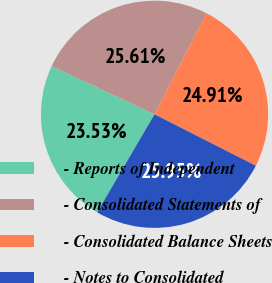Convert chart. <chart><loc_0><loc_0><loc_500><loc_500><pie_chart><fcel>- Reports of Independent<fcel>- Consolidated Statements of<fcel>- Consolidated Balance Sheets<fcel>- Notes to Consolidated<nl><fcel>23.53%<fcel>25.61%<fcel>24.91%<fcel>25.95%<nl></chart> 